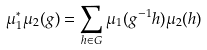Convert formula to latex. <formula><loc_0><loc_0><loc_500><loc_500>\mu _ { 1 } ^ { * } \mu _ { 2 } ( g ) = \sum _ { h \in G } \mu _ { 1 } ( g ^ { - 1 } h ) \mu _ { 2 } ( h )</formula> 